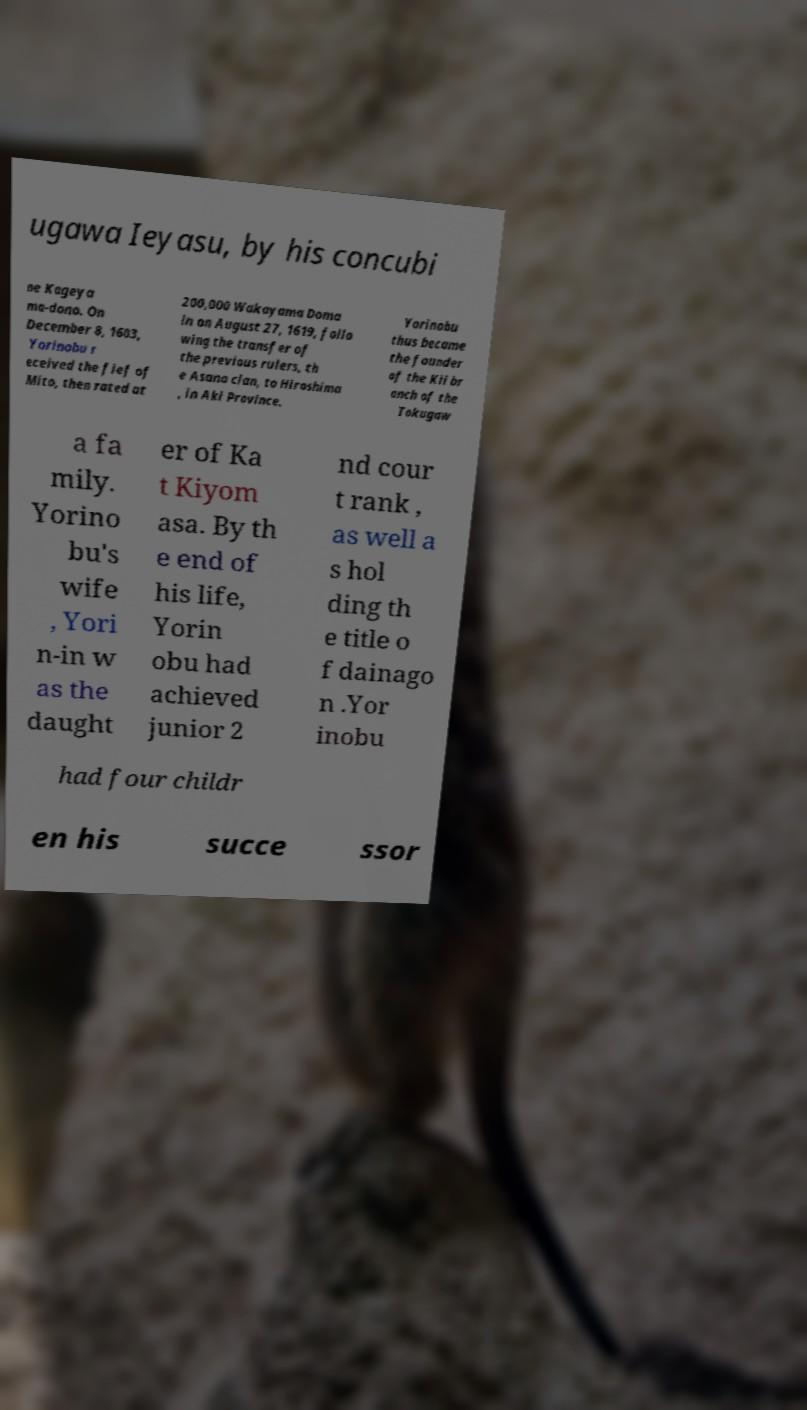Can you read and provide the text displayed in the image?This photo seems to have some interesting text. Can you extract and type it out for me? ugawa Ieyasu, by his concubi ne Kageya ma-dono. On December 8, 1603, Yorinobu r eceived the fief of Mito, then rated at 200,000 Wakayama Doma in on August 27, 1619, follo wing the transfer of the previous rulers, th e Asano clan, to Hiroshima , in Aki Province. Yorinobu thus became the founder of the Kii br anch of the Tokugaw a fa mily. Yorino bu's wife , Yori n-in w as the daught er of Ka t Kiyom asa. By th e end of his life, Yorin obu had achieved junior 2 nd cour t rank , as well a s hol ding th e title o f dainago n .Yor inobu had four childr en his succe ssor 